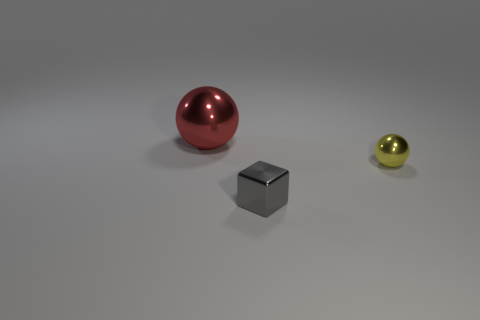Add 2 gray objects. How many objects exist? 5 Subtract all blocks. How many objects are left? 2 Subtract 0 blue spheres. How many objects are left? 3 Subtract all spheres. Subtract all gray metallic blocks. How many objects are left? 0 Add 1 gray blocks. How many gray blocks are left? 2 Add 1 tiny blue rubber things. How many tiny blue rubber things exist? 1 